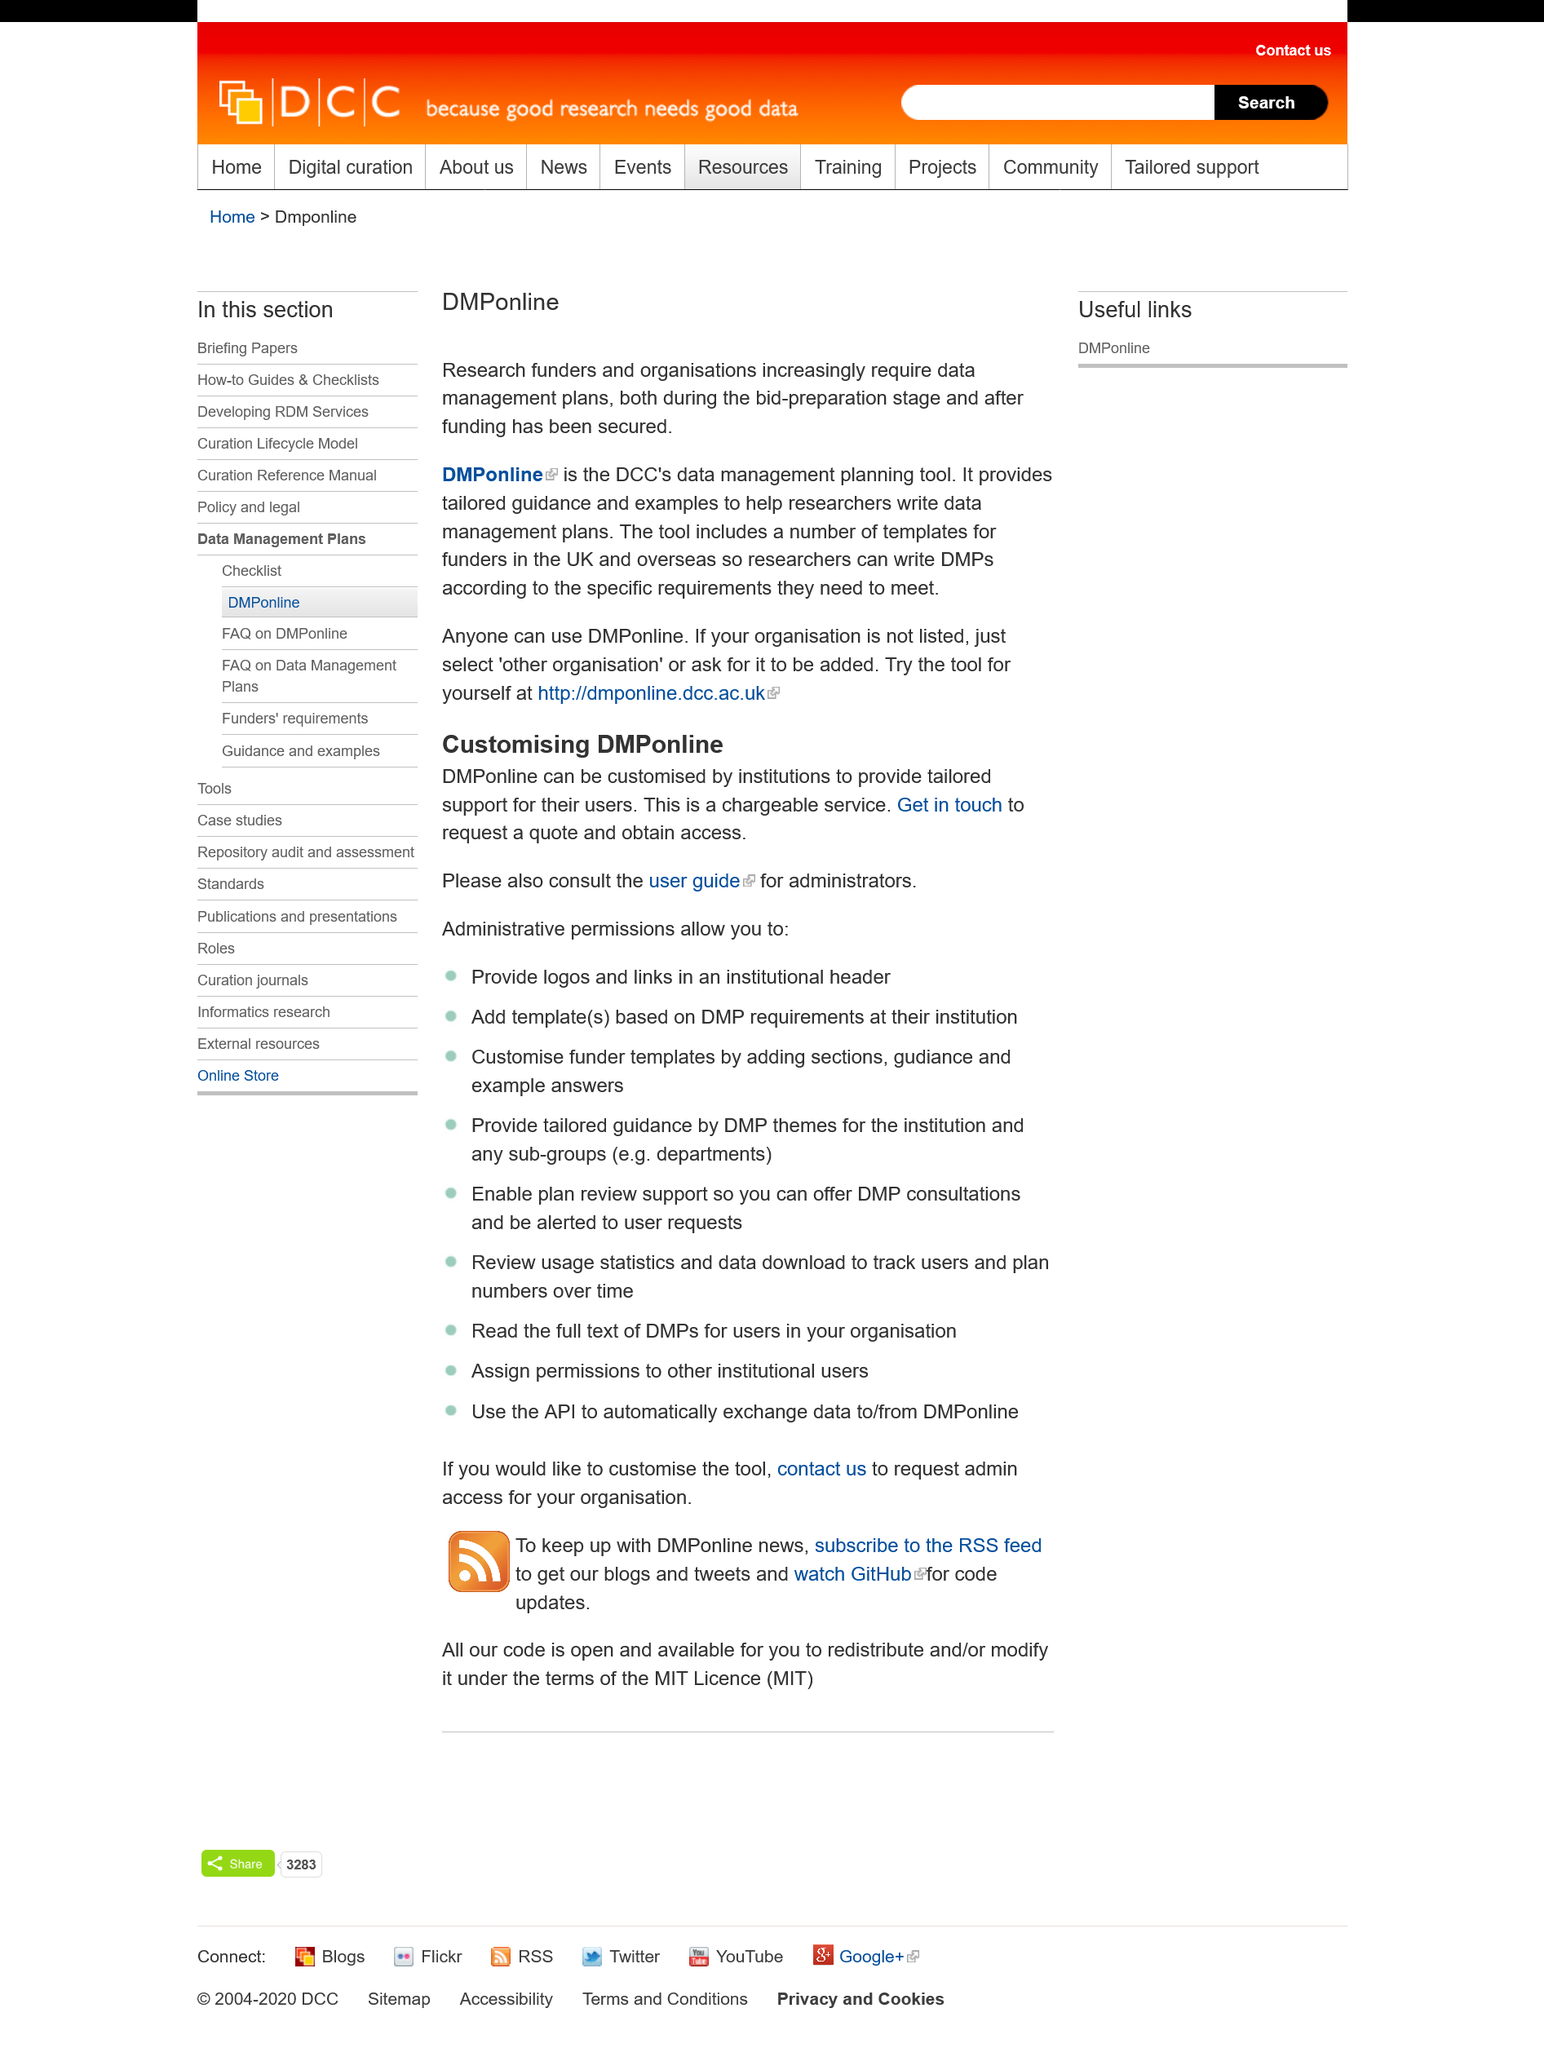Identify some key points in this picture. DCCs data management tool is called DMP online. The title of this page is "DMP online". This page is dedicated to DMPonline. 